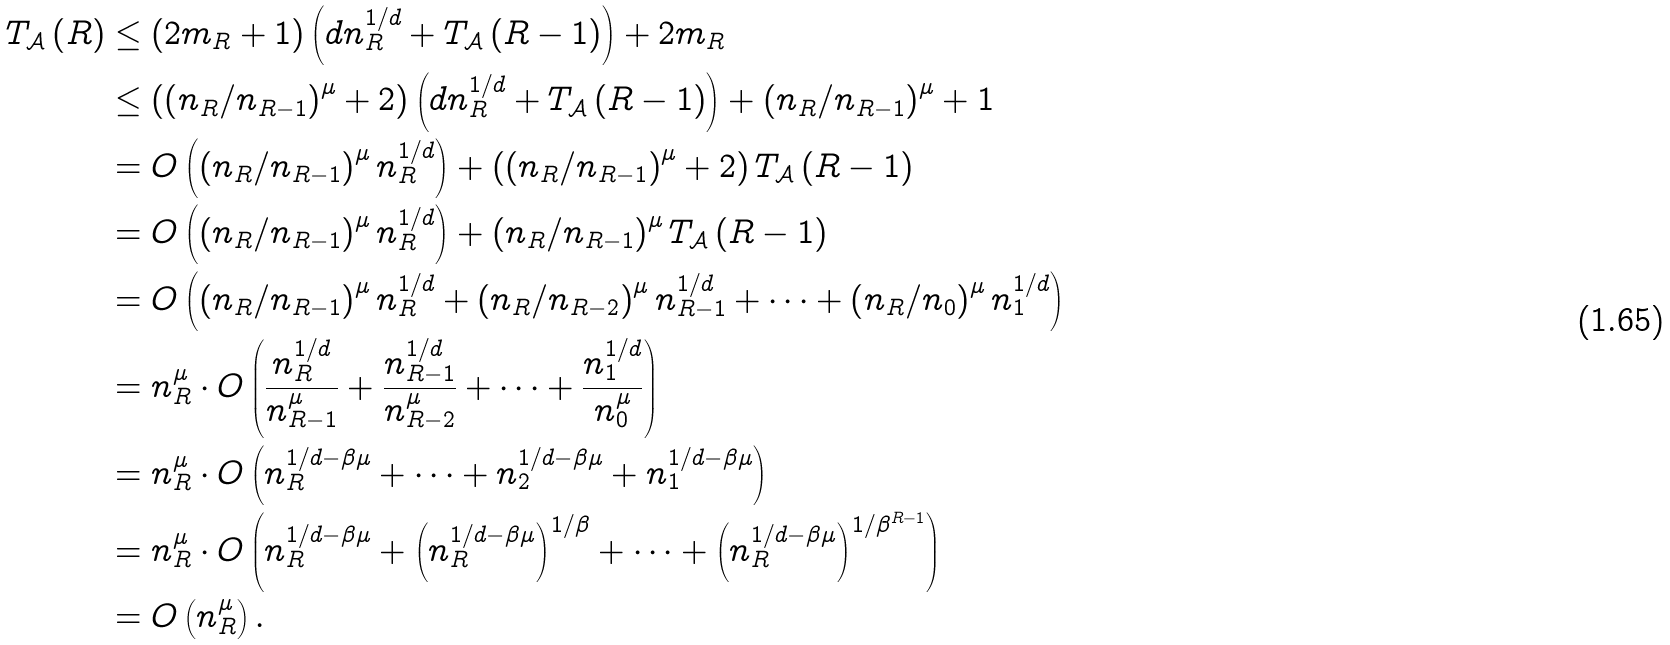Convert formula to latex. <formula><loc_0><loc_0><loc_500><loc_500>T _ { \mathcal { A } } \left ( R \right ) & \leq \left ( 2 m _ { R } + 1 \right ) \left ( d n _ { R } ^ { 1 / d } + T _ { \mathcal { A } } \left ( R - 1 \right ) \right ) + 2 m _ { R } \\ & \leq \left ( \left ( n _ { R } / n _ { R - 1 } \right ) ^ { \mu } + 2 \right ) \left ( d n _ { R } ^ { 1 / d } + T _ { \mathcal { A } } \left ( R - 1 \right ) \right ) + \left ( n _ { R } / n _ { R - 1 } \right ) ^ { \mu } + 1 \\ & = O \left ( \left ( n _ { R } / n _ { R - 1 } \right ) ^ { \mu } n _ { R } ^ { 1 / d } \right ) + \left ( \left ( n _ { R } / n _ { R - 1 } \right ) ^ { \mu } + 2 \right ) T _ { \mathcal { A } } \left ( R - 1 \right ) \\ & = O \left ( \left ( n _ { R } / n _ { R - 1 } \right ) ^ { \mu } n _ { R } ^ { 1 / d } \right ) + \left ( n _ { R } / n _ { R - 1 } \right ) ^ { \mu } T _ { \mathcal { A } } \left ( R - 1 \right ) \\ & = O \left ( \left ( n _ { R } / n _ { R - 1 } \right ) ^ { \mu } n _ { R } ^ { 1 / d } + \left ( n _ { R } / n _ { R - 2 } \right ) ^ { \mu } n _ { R - 1 } ^ { 1 / d } + \cdots + \left ( n _ { R } / n _ { 0 } \right ) ^ { \mu } n _ { 1 } ^ { 1 / d } \right ) \\ & = n _ { R } ^ { \mu } \cdot O \left ( \frac { n _ { R } ^ { 1 / d } } { n _ { R - 1 } ^ { \mu } } + \frac { n _ { R - 1 } ^ { 1 / d } } { n _ { R - 2 } ^ { \mu } } + \cdots + \frac { n _ { 1 } ^ { 1 / d } } { n _ { 0 } ^ { \mu } } \right ) \\ & = n _ { R } ^ { \mu } \cdot O \left ( n _ { R } ^ { 1 / d - \beta \mu } + \cdots + n _ { 2 } ^ { 1 / d - \beta \mu } + n _ { 1 } ^ { 1 / d - \beta \mu } \right ) \\ & = n _ { R } ^ { \mu } \cdot O \left ( n _ { R } ^ { 1 / d - \beta \mu } + \left ( n _ { R } ^ { 1 / d - \beta \mu } \right ) ^ { 1 / \beta } + \cdots + \left ( n _ { R } ^ { 1 / d - \beta \mu } \right ) ^ { 1 / \beta ^ { R - 1 } } \right ) \\ & = O \left ( n _ { R } ^ { \mu } \right ) .</formula> 